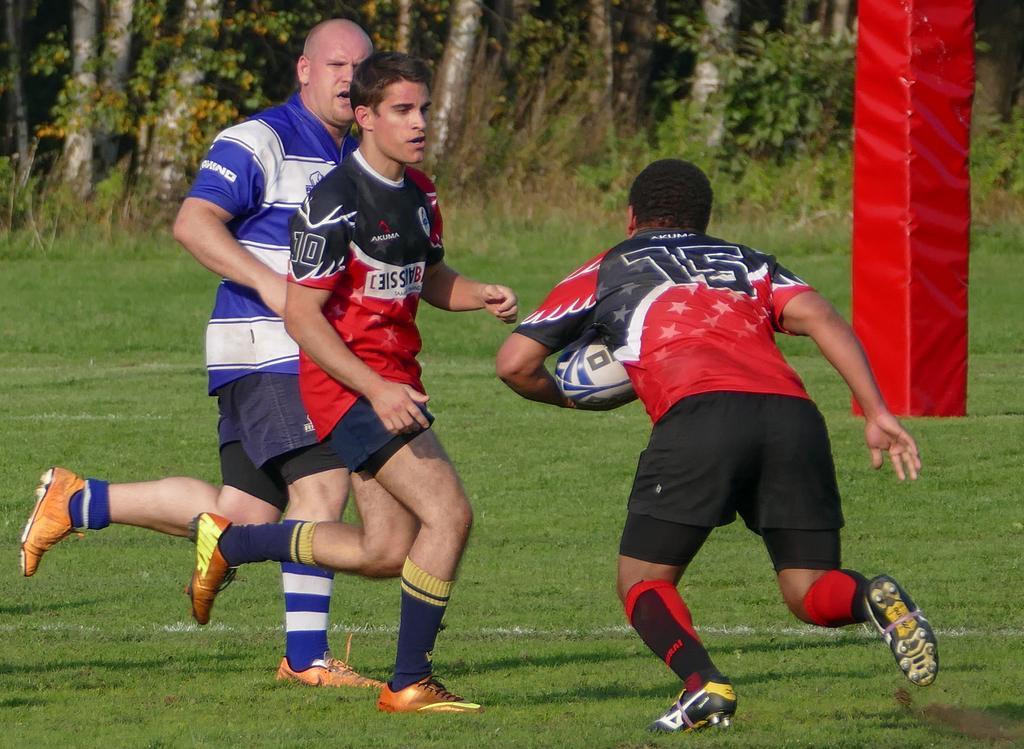Could you give a brief overview of what you see in this image? This picture shows three men playing football and we see few trees around and a greenfield 